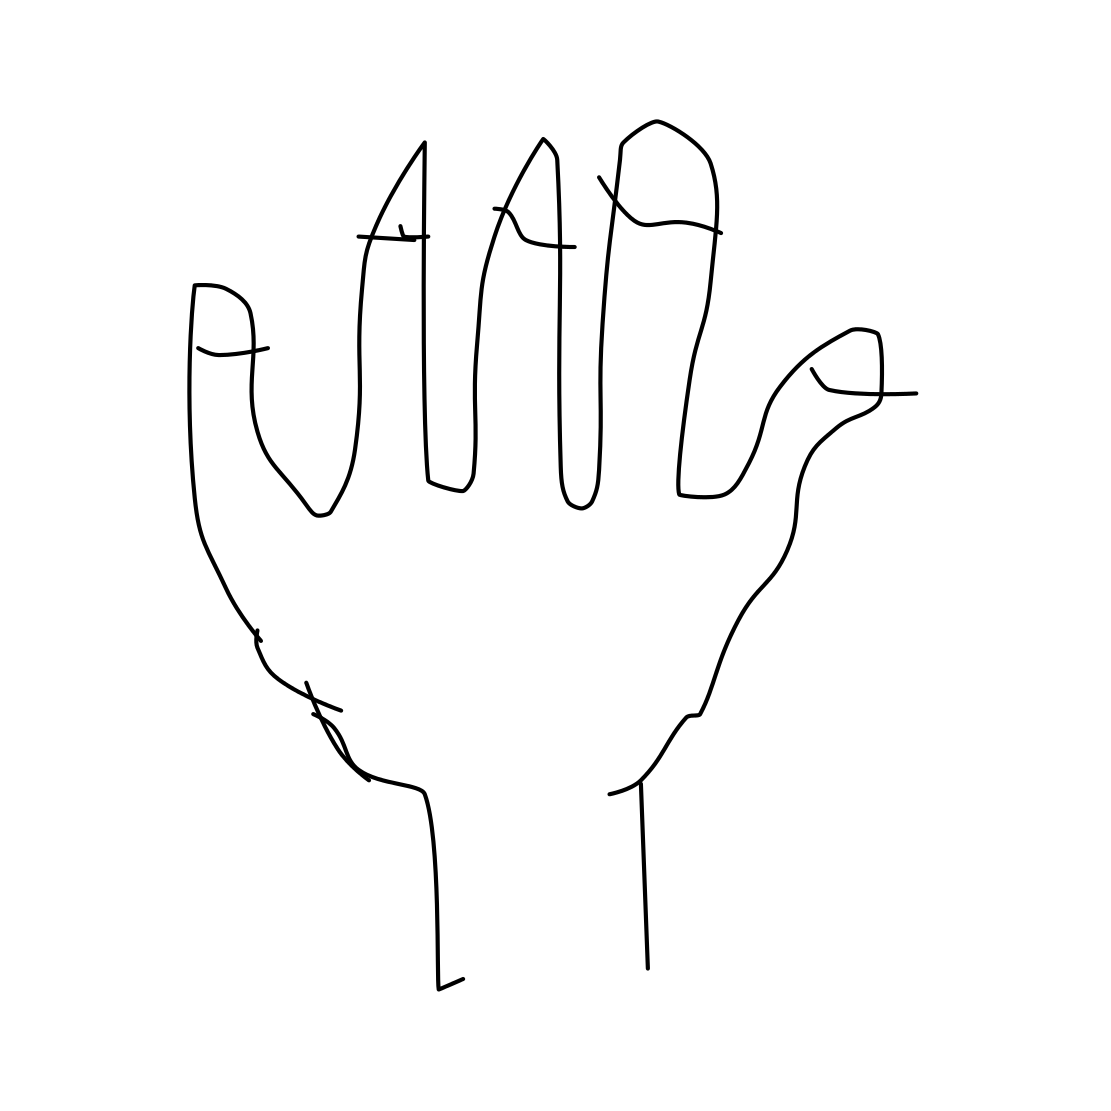Can you tell me something about the style of this drawing? Certainly! The drawing exhibits a very simplistic and abstract style, utilizing unembellished lines with minimal detail to convey the outline and structure of a human hand. This style can be appreciated for its clarity and could be an example of line art used in various forms of design and education. 